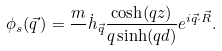Convert formula to latex. <formula><loc_0><loc_0><loc_500><loc_500>\phi _ { s } ( \vec { q } \, ) = \frac { m } { } \dot { h } _ { \vec { q } } \frac { \cosh ( q z ) } { q \sinh ( q d ) } e ^ { i \vec { q } \cdot \vec { R } } .</formula> 